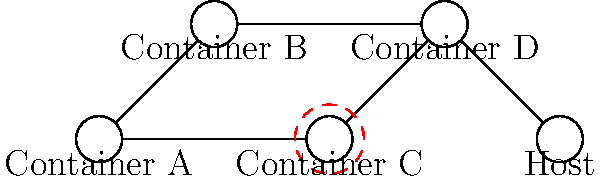In the Docker container network topology shown above, which container represents a potential security vulnerability, and what network security principle should be applied to mitigate this risk? To answer this question, let's analyze the Docker container network topology step by step:

1. The diagram shows five nodes: four containers (A, B, C, and D) and the host system.

2. Container C is highlighted with a red dashed circle, indicating a potential security vulnerability.

3. Examining the network connections:
   - Container A is connected to both B and C
   - Container B is connected to D
   - Container C is connected to D
   - Container D is connected to the host system

4. The topology suggests that Container C has a direct connection to Container D, which in turn has access to the host system.

5. This setup violates the principle of least privilege, as Container C potentially has unnecessary access to the host system through Container D.

6. To mitigate this risk, we should apply the principle of network segmentation.

7. Network segmentation involves dividing the network into smaller, isolated segments to limit the potential spread of security breaches and reduce the attack surface.

8. In this case, we should isolate Container C from direct access to Container D, thereby preventing any potential security vulnerabilities in C from affecting the host system.
Answer: Container C; Network segmentation 